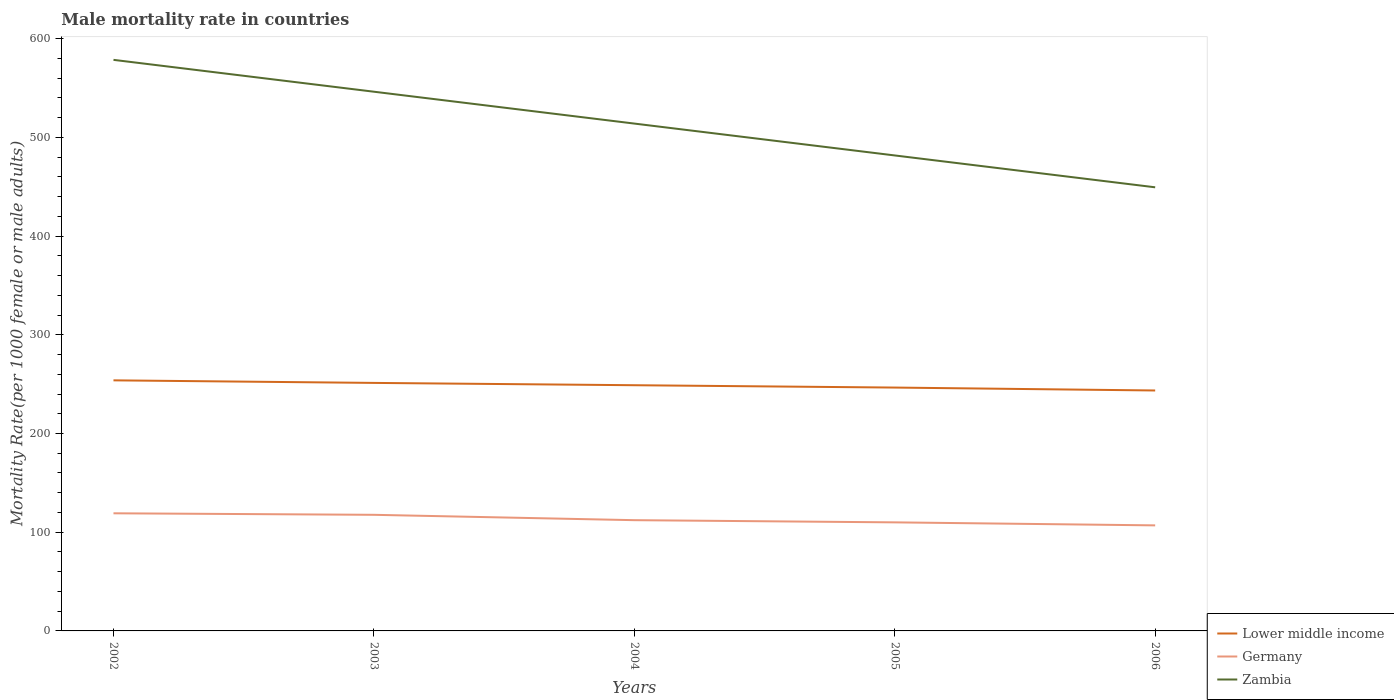How many different coloured lines are there?
Your response must be concise. 3. Does the line corresponding to Germany intersect with the line corresponding to Zambia?
Give a very brief answer. No. Is the number of lines equal to the number of legend labels?
Your answer should be compact. Yes. Across all years, what is the maximum male mortality rate in Lower middle income?
Your answer should be very brief. 243.57. What is the total male mortality rate in Germany in the graph?
Make the answer very short. 2.21. What is the difference between the highest and the second highest male mortality rate in Zambia?
Offer a very short reply. 129.11. What is the difference between two consecutive major ticks on the Y-axis?
Offer a very short reply. 100. Does the graph contain grids?
Offer a very short reply. No. How are the legend labels stacked?
Provide a short and direct response. Vertical. What is the title of the graph?
Offer a terse response. Male mortality rate in countries. What is the label or title of the X-axis?
Keep it short and to the point. Years. What is the label or title of the Y-axis?
Make the answer very short. Mortality Rate(per 1000 female or male adults). What is the Mortality Rate(per 1000 female or male adults) in Lower middle income in 2002?
Provide a short and direct response. 253.84. What is the Mortality Rate(per 1000 female or male adults) of Germany in 2002?
Keep it short and to the point. 119.16. What is the Mortality Rate(per 1000 female or male adults) of Zambia in 2002?
Your response must be concise. 578.52. What is the Mortality Rate(per 1000 female or male adults) in Lower middle income in 2003?
Make the answer very short. 251.25. What is the Mortality Rate(per 1000 female or male adults) of Germany in 2003?
Ensure brevity in your answer.  117.62. What is the Mortality Rate(per 1000 female or male adults) of Zambia in 2003?
Ensure brevity in your answer.  546.24. What is the Mortality Rate(per 1000 female or male adults) in Lower middle income in 2004?
Provide a short and direct response. 248.9. What is the Mortality Rate(per 1000 female or male adults) in Germany in 2004?
Ensure brevity in your answer.  112.2. What is the Mortality Rate(per 1000 female or male adults) in Zambia in 2004?
Offer a very short reply. 513.96. What is the Mortality Rate(per 1000 female or male adults) of Lower middle income in 2005?
Your answer should be very brief. 246.53. What is the Mortality Rate(per 1000 female or male adults) of Germany in 2005?
Your answer should be compact. 109.98. What is the Mortality Rate(per 1000 female or male adults) in Zambia in 2005?
Keep it short and to the point. 481.68. What is the Mortality Rate(per 1000 female or male adults) in Lower middle income in 2006?
Provide a short and direct response. 243.57. What is the Mortality Rate(per 1000 female or male adults) of Germany in 2006?
Ensure brevity in your answer.  106.92. What is the Mortality Rate(per 1000 female or male adults) in Zambia in 2006?
Offer a terse response. 449.41. Across all years, what is the maximum Mortality Rate(per 1000 female or male adults) in Lower middle income?
Make the answer very short. 253.84. Across all years, what is the maximum Mortality Rate(per 1000 female or male adults) of Germany?
Provide a short and direct response. 119.16. Across all years, what is the maximum Mortality Rate(per 1000 female or male adults) in Zambia?
Keep it short and to the point. 578.52. Across all years, what is the minimum Mortality Rate(per 1000 female or male adults) in Lower middle income?
Keep it short and to the point. 243.57. Across all years, what is the minimum Mortality Rate(per 1000 female or male adults) of Germany?
Keep it short and to the point. 106.92. Across all years, what is the minimum Mortality Rate(per 1000 female or male adults) in Zambia?
Your answer should be very brief. 449.41. What is the total Mortality Rate(per 1000 female or male adults) of Lower middle income in the graph?
Your answer should be very brief. 1244.09. What is the total Mortality Rate(per 1000 female or male adults) in Germany in the graph?
Keep it short and to the point. 565.88. What is the total Mortality Rate(per 1000 female or male adults) in Zambia in the graph?
Ensure brevity in your answer.  2569.81. What is the difference between the Mortality Rate(per 1000 female or male adults) in Lower middle income in 2002 and that in 2003?
Your response must be concise. 2.59. What is the difference between the Mortality Rate(per 1000 female or male adults) of Germany in 2002 and that in 2003?
Make the answer very short. 1.54. What is the difference between the Mortality Rate(per 1000 female or male adults) of Zambia in 2002 and that in 2003?
Your response must be concise. 32.28. What is the difference between the Mortality Rate(per 1000 female or male adults) of Lower middle income in 2002 and that in 2004?
Ensure brevity in your answer.  4.94. What is the difference between the Mortality Rate(per 1000 female or male adults) of Germany in 2002 and that in 2004?
Your answer should be very brief. 6.96. What is the difference between the Mortality Rate(per 1000 female or male adults) of Zambia in 2002 and that in 2004?
Keep it short and to the point. 64.56. What is the difference between the Mortality Rate(per 1000 female or male adults) of Lower middle income in 2002 and that in 2005?
Provide a short and direct response. 7.31. What is the difference between the Mortality Rate(per 1000 female or male adults) of Germany in 2002 and that in 2005?
Ensure brevity in your answer.  9.18. What is the difference between the Mortality Rate(per 1000 female or male adults) in Zambia in 2002 and that in 2005?
Offer a terse response. 96.83. What is the difference between the Mortality Rate(per 1000 female or male adults) in Lower middle income in 2002 and that in 2006?
Make the answer very short. 10.27. What is the difference between the Mortality Rate(per 1000 female or male adults) of Germany in 2002 and that in 2006?
Ensure brevity in your answer.  12.24. What is the difference between the Mortality Rate(per 1000 female or male adults) of Zambia in 2002 and that in 2006?
Your answer should be compact. 129.11. What is the difference between the Mortality Rate(per 1000 female or male adults) in Lower middle income in 2003 and that in 2004?
Offer a very short reply. 2.35. What is the difference between the Mortality Rate(per 1000 female or male adults) of Germany in 2003 and that in 2004?
Offer a terse response. 5.43. What is the difference between the Mortality Rate(per 1000 female or male adults) in Zambia in 2003 and that in 2004?
Provide a succinct answer. 32.28. What is the difference between the Mortality Rate(per 1000 female or male adults) of Lower middle income in 2003 and that in 2005?
Your response must be concise. 4.72. What is the difference between the Mortality Rate(per 1000 female or male adults) of Germany in 2003 and that in 2005?
Offer a terse response. 7.64. What is the difference between the Mortality Rate(per 1000 female or male adults) in Zambia in 2003 and that in 2005?
Make the answer very short. 64.56. What is the difference between the Mortality Rate(per 1000 female or male adults) of Lower middle income in 2003 and that in 2006?
Offer a terse response. 7.68. What is the difference between the Mortality Rate(per 1000 female or male adults) in Zambia in 2003 and that in 2006?
Provide a short and direct response. 96.83. What is the difference between the Mortality Rate(per 1000 female or male adults) in Lower middle income in 2004 and that in 2005?
Offer a terse response. 2.37. What is the difference between the Mortality Rate(per 1000 female or male adults) in Germany in 2004 and that in 2005?
Offer a terse response. 2.21. What is the difference between the Mortality Rate(per 1000 female or male adults) in Zambia in 2004 and that in 2005?
Keep it short and to the point. 32.28. What is the difference between the Mortality Rate(per 1000 female or male adults) in Lower middle income in 2004 and that in 2006?
Give a very brief answer. 5.33. What is the difference between the Mortality Rate(per 1000 female or male adults) of Germany in 2004 and that in 2006?
Offer a very short reply. 5.27. What is the difference between the Mortality Rate(per 1000 female or male adults) of Zambia in 2004 and that in 2006?
Provide a short and direct response. 64.56. What is the difference between the Mortality Rate(per 1000 female or male adults) in Lower middle income in 2005 and that in 2006?
Make the answer very short. 2.96. What is the difference between the Mortality Rate(per 1000 female or male adults) of Germany in 2005 and that in 2006?
Provide a succinct answer. 3.06. What is the difference between the Mortality Rate(per 1000 female or male adults) in Zambia in 2005 and that in 2006?
Your answer should be compact. 32.28. What is the difference between the Mortality Rate(per 1000 female or male adults) in Lower middle income in 2002 and the Mortality Rate(per 1000 female or male adults) in Germany in 2003?
Give a very brief answer. 136.21. What is the difference between the Mortality Rate(per 1000 female or male adults) of Lower middle income in 2002 and the Mortality Rate(per 1000 female or male adults) of Zambia in 2003?
Offer a very short reply. -292.4. What is the difference between the Mortality Rate(per 1000 female or male adults) of Germany in 2002 and the Mortality Rate(per 1000 female or male adults) of Zambia in 2003?
Ensure brevity in your answer.  -427.08. What is the difference between the Mortality Rate(per 1000 female or male adults) of Lower middle income in 2002 and the Mortality Rate(per 1000 female or male adults) of Germany in 2004?
Keep it short and to the point. 141.64. What is the difference between the Mortality Rate(per 1000 female or male adults) in Lower middle income in 2002 and the Mortality Rate(per 1000 female or male adults) in Zambia in 2004?
Offer a very short reply. -260.12. What is the difference between the Mortality Rate(per 1000 female or male adults) in Germany in 2002 and the Mortality Rate(per 1000 female or male adults) in Zambia in 2004?
Keep it short and to the point. -394.8. What is the difference between the Mortality Rate(per 1000 female or male adults) of Lower middle income in 2002 and the Mortality Rate(per 1000 female or male adults) of Germany in 2005?
Make the answer very short. 143.85. What is the difference between the Mortality Rate(per 1000 female or male adults) in Lower middle income in 2002 and the Mortality Rate(per 1000 female or male adults) in Zambia in 2005?
Make the answer very short. -227.85. What is the difference between the Mortality Rate(per 1000 female or male adults) in Germany in 2002 and the Mortality Rate(per 1000 female or male adults) in Zambia in 2005?
Keep it short and to the point. -362.52. What is the difference between the Mortality Rate(per 1000 female or male adults) of Lower middle income in 2002 and the Mortality Rate(per 1000 female or male adults) of Germany in 2006?
Provide a succinct answer. 146.91. What is the difference between the Mortality Rate(per 1000 female or male adults) in Lower middle income in 2002 and the Mortality Rate(per 1000 female or male adults) in Zambia in 2006?
Provide a succinct answer. -195.57. What is the difference between the Mortality Rate(per 1000 female or male adults) in Germany in 2002 and the Mortality Rate(per 1000 female or male adults) in Zambia in 2006?
Offer a terse response. -330.25. What is the difference between the Mortality Rate(per 1000 female or male adults) in Lower middle income in 2003 and the Mortality Rate(per 1000 female or male adults) in Germany in 2004?
Your answer should be very brief. 139.06. What is the difference between the Mortality Rate(per 1000 female or male adults) in Lower middle income in 2003 and the Mortality Rate(per 1000 female or male adults) in Zambia in 2004?
Keep it short and to the point. -262.71. What is the difference between the Mortality Rate(per 1000 female or male adults) of Germany in 2003 and the Mortality Rate(per 1000 female or male adults) of Zambia in 2004?
Make the answer very short. -396.34. What is the difference between the Mortality Rate(per 1000 female or male adults) in Lower middle income in 2003 and the Mortality Rate(per 1000 female or male adults) in Germany in 2005?
Ensure brevity in your answer.  141.27. What is the difference between the Mortality Rate(per 1000 female or male adults) in Lower middle income in 2003 and the Mortality Rate(per 1000 female or male adults) in Zambia in 2005?
Make the answer very short. -230.43. What is the difference between the Mortality Rate(per 1000 female or male adults) in Germany in 2003 and the Mortality Rate(per 1000 female or male adults) in Zambia in 2005?
Offer a terse response. -364.06. What is the difference between the Mortality Rate(per 1000 female or male adults) in Lower middle income in 2003 and the Mortality Rate(per 1000 female or male adults) in Germany in 2006?
Keep it short and to the point. 144.33. What is the difference between the Mortality Rate(per 1000 female or male adults) of Lower middle income in 2003 and the Mortality Rate(per 1000 female or male adults) of Zambia in 2006?
Your response must be concise. -198.15. What is the difference between the Mortality Rate(per 1000 female or male adults) of Germany in 2003 and the Mortality Rate(per 1000 female or male adults) of Zambia in 2006?
Keep it short and to the point. -331.78. What is the difference between the Mortality Rate(per 1000 female or male adults) in Lower middle income in 2004 and the Mortality Rate(per 1000 female or male adults) in Germany in 2005?
Your answer should be very brief. 138.92. What is the difference between the Mortality Rate(per 1000 female or male adults) in Lower middle income in 2004 and the Mortality Rate(per 1000 female or male adults) in Zambia in 2005?
Your answer should be compact. -232.78. What is the difference between the Mortality Rate(per 1000 female or male adults) in Germany in 2004 and the Mortality Rate(per 1000 female or male adults) in Zambia in 2005?
Ensure brevity in your answer.  -369.49. What is the difference between the Mortality Rate(per 1000 female or male adults) in Lower middle income in 2004 and the Mortality Rate(per 1000 female or male adults) in Germany in 2006?
Offer a very short reply. 141.98. What is the difference between the Mortality Rate(per 1000 female or male adults) in Lower middle income in 2004 and the Mortality Rate(per 1000 female or male adults) in Zambia in 2006?
Your answer should be compact. -200.5. What is the difference between the Mortality Rate(per 1000 female or male adults) of Germany in 2004 and the Mortality Rate(per 1000 female or male adults) of Zambia in 2006?
Offer a very short reply. -337.21. What is the difference between the Mortality Rate(per 1000 female or male adults) of Lower middle income in 2005 and the Mortality Rate(per 1000 female or male adults) of Germany in 2006?
Provide a short and direct response. 139.61. What is the difference between the Mortality Rate(per 1000 female or male adults) in Lower middle income in 2005 and the Mortality Rate(per 1000 female or male adults) in Zambia in 2006?
Provide a short and direct response. -202.87. What is the difference between the Mortality Rate(per 1000 female or male adults) in Germany in 2005 and the Mortality Rate(per 1000 female or male adults) in Zambia in 2006?
Ensure brevity in your answer.  -339.42. What is the average Mortality Rate(per 1000 female or male adults) in Lower middle income per year?
Your response must be concise. 248.82. What is the average Mortality Rate(per 1000 female or male adults) in Germany per year?
Your answer should be very brief. 113.18. What is the average Mortality Rate(per 1000 female or male adults) of Zambia per year?
Your response must be concise. 513.96. In the year 2002, what is the difference between the Mortality Rate(per 1000 female or male adults) in Lower middle income and Mortality Rate(per 1000 female or male adults) in Germany?
Make the answer very short. 134.68. In the year 2002, what is the difference between the Mortality Rate(per 1000 female or male adults) of Lower middle income and Mortality Rate(per 1000 female or male adults) of Zambia?
Your answer should be compact. -324.68. In the year 2002, what is the difference between the Mortality Rate(per 1000 female or male adults) of Germany and Mortality Rate(per 1000 female or male adults) of Zambia?
Keep it short and to the point. -459.36. In the year 2003, what is the difference between the Mortality Rate(per 1000 female or male adults) of Lower middle income and Mortality Rate(per 1000 female or male adults) of Germany?
Make the answer very short. 133.63. In the year 2003, what is the difference between the Mortality Rate(per 1000 female or male adults) in Lower middle income and Mortality Rate(per 1000 female or male adults) in Zambia?
Ensure brevity in your answer.  -294.99. In the year 2003, what is the difference between the Mortality Rate(per 1000 female or male adults) of Germany and Mortality Rate(per 1000 female or male adults) of Zambia?
Keep it short and to the point. -428.62. In the year 2004, what is the difference between the Mortality Rate(per 1000 female or male adults) in Lower middle income and Mortality Rate(per 1000 female or male adults) in Germany?
Give a very brief answer. 136.71. In the year 2004, what is the difference between the Mortality Rate(per 1000 female or male adults) in Lower middle income and Mortality Rate(per 1000 female or male adults) in Zambia?
Make the answer very short. -265.06. In the year 2004, what is the difference between the Mortality Rate(per 1000 female or male adults) of Germany and Mortality Rate(per 1000 female or male adults) of Zambia?
Your answer should be very brief. -401.77. In the year 2005, what is the difference between the Mortality Rate(per 1000 female or male adults) of Lower middle income and Mortality Rate(per 1000 female or male adults) of Germany?
Provide a short and direct response. 136.55. In the year 2005, what is the difference between the Mortality Rate(per 1000 female or male adults) of Lower middle income and Mortality Rate(per 1000 female or male adults) of Zambia?
Keep it short and to the point. -235.15. In the year 2005, what is the difference between the Mortality Rate(per 1000 female or male adults) of Germany and Mortality Rate(per 1000 female or male adults) of Zambia?
Your answer should be compact. -371.7. In the year 2006, what is the difference between the Mortality Rate(per 1000 female or male adults) of Lower middle income and Mortality Rate(per 1000 female or male adults) of Germany?
Make the answer very short. 136.65. In the year 2006, what is the difference between the Mortality Rate(per 1000 female or male adults) of Lower middle income and Mortality Rate(per 1000 female or male adults) of Zambia?
Provide a short and direct response. -205.84. In the year 2006, what is the difference between the Mortality Rate(per 1000 female or male adults) of Germany and Mortality Rate(per 1000 female or male adults) of Zambia?
Make the answer very short. -342.48. What is the ratio of the Mortality Rate(per 1000 female or male adults) in Lower middle income in 2002 to that in 2003?
Provide a succinct answer. 1.01. What is the ratio of the Mortality Rate(per 1000 female or male adults) of Germany in 2002 to that in 2003?
Provide a short and direct response. 1.01. What is the ratio of the Mortality Rate(per 1000 female or male adults) of Zambia in 2002 to that in 2003?
Give a very brief answer. 1.06. What is the ratio of the Mortality Rate(per 1000 female or male adults) in Lower middle income in 2002 to that in 2004?
Keep it short and to the point. 1.02. What is the ratio of the Mortality Rate(per 1000 female or male adults) in Germany in 2002 to that in 2004?
Ensure brevity in your answer.  1.06. What is the ratio of the Mortality Rate(per 1000 female or male adults) in Zambia in 2002 to that in 2004?
Provide a short and direct response. 1.13. What is the ratio of the Mortality Rate(per 1000 female or male adults) of Lower middle income in 2002 to that in 2005?
Provide a short and direct response. 1.03. What is the ratio of the Mortality Rate(per 1000 female or male adults) of Germany in 2002 to that in 2005?
Give a very brief answer. 1.08. What is the ratio of the Mortality Rate(per 1000 female or male adults) in Zambia in 2002 to that in 2005?
Ensure brevity in your answer.  1.2. What is the ratio of the Mortality Rate(per 1000 female or male adults) of Lower middle income in 2002 to that in 2006?
Offer a very short reply. 1.04. What is the ratio of the Mortality Rate(per 1000 female or male adults) of Germany in 2002 to that in 2006?
Keep it short and to the point. 1.11. What is the ratio of the Mortality Rate(per 1000 female or male adults) of Zambia in 2002 to that in 2006?
Offer a very short reply. 1.29. What is the ratio of the Mortality Rate(per 1000 female or male adults) of Lower middle income in 2003 to that in 2004?
Ensure brevity in your answer.  1.01. What is the ratio of the Mortality Rate(per 1000 female or male adults) of Germany in 2003 to that in 2004?
Give a very brief answer. 1.05. What is the ratio of the Mortality Rate(per 1000 female or male adults) in Zambia in 2003 to that in 2004?
Provide a succinct answer. 1.06. What is the ratio of the Mortality Rate(per 1000 female or male adults) in Lower middle income in 2003 to that in 2005?
Offer a terse response. 1.02. What is the ratio of the Mortality Rate(per 1000 female or male adults) of Germany in 2003 to that in 2005?
Your answer should be compact. 1.07. What is the ratio of the Mortality Rate(per 1000 female or male adults) of Zambia in 2003 to that in 2005?
Make the answer very short. 1.13. What is the ratio of the Mortality Rate(per 1000 female or male adults) in Lower middle income in 2003 to that in 2006?
Make the answer very short. 1.03. What is the ratio of the Mortality Rate(per 1000 female or male adults) in Germany in 2003 to that in 2006?
Offer a very short reply. 1.1. What is the ratio of the Mortality Rate(per 1000 female or male adults) of Zambia in 2003 to that in 2006?
Your answer should be compact. 1.22. What is the ratio of the Mortality Rate(per 1000 female or male adults) in Lower middle income in 2004 to that in 2005?
Make the answer very short. 1.01. What is the ratio of the Mortality Rate(per 1000 female or male adults) of Germany in 2004 to that in 2005?
Offer a terse response. 1.02. What is the ratio of the Mortality Rate(per 1000 female or male adults) in Zambia in 2004 to that in 2005?
Provide a succinct answer. 1.07. What is the ratio of the Mortality Rate(per 1000 female or male adults) of Lower middle income in 2004 to that in 2006?
Keep it short and to the point. 1.02. What is the ratio of the Mortality Rate(per 1000 female or male adults) of Germany in 2004 to that in 2006?
Your answer should be very brief. 1.05. What is the ratio of the Mortality Rate(per 1000 female or male adults) in Zambia in 2004 to that in 2006?
Keep it short and to the point. 1.14. What is the ratio of the Mortality Rate(per 1000 female or male adults) of Lower middle income in 2005 to that in 2006?
Your answer should be very brief. 1.01. What is the ratio of the Mortality Rate(per 1000 female or male adults) in Germany in 2005 to that in 2006?
Your answer should be compact. 1.03. What is the ratio of the Mortality Rate(per 1000 female or male adults) in Zambia in 2005 to that in 2006?
Your answer should be compact. 1.07. What is the difference between the highest and the second highest Mortality Rate(per 1000 female or male adults) in Lower middle income?
Your response must be concise. 2.59. What is the difference between the highest and the second highest Mortality Rate(per 1000 female or male adults) of Germany?
Give a very brief answer. 1.54. What is the difference between the highest and the second highest Mortality Rate(per 1000 female or male adults) of Zambia?
Make the answer very short. 32.28. What is the difference between the highest and the lowest Mortality Rate(per 1000 female or male adults) of Lower middle income?
Your answer should be very brief. 10.27. What is the difference between the highest and the lowest Mortality Rate(per 1000 female or male adults) in Germany?
Offer a very short reply. 12.24. What is the difference between the highest and the lowest Mortality Rate(per 1000 female or male adults) in Zambia?
Offer a very short reply. 129.11. 